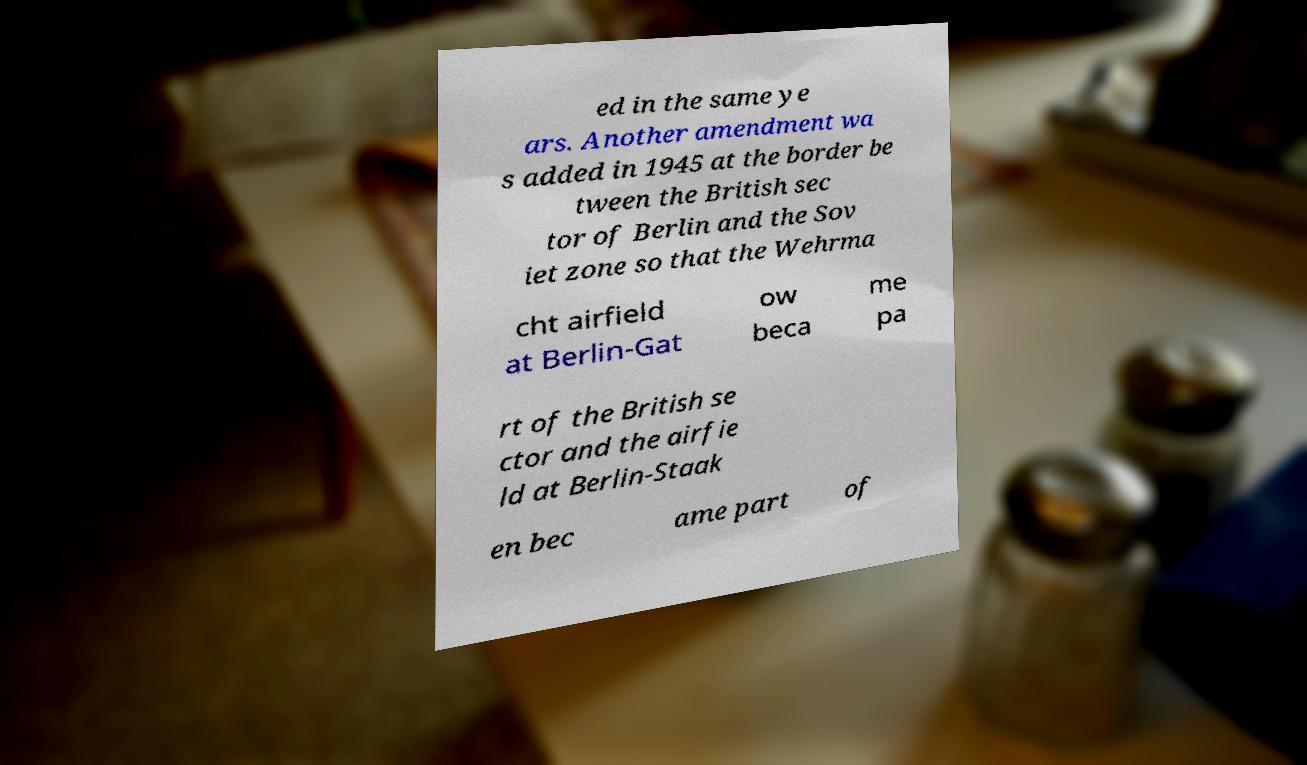Please read and relay the text visible in this image. What does it say? ed in the same ye ars. Another amendment wa s added in 1945 at the border be tween the British sec tor of Berlin and the Sov iet zone so that the Wehrma cht airfield at Berlin-Gat ow beca me pa rt of the British se ctor and the airfie ld at Berlin-Staak en bec ame part of 